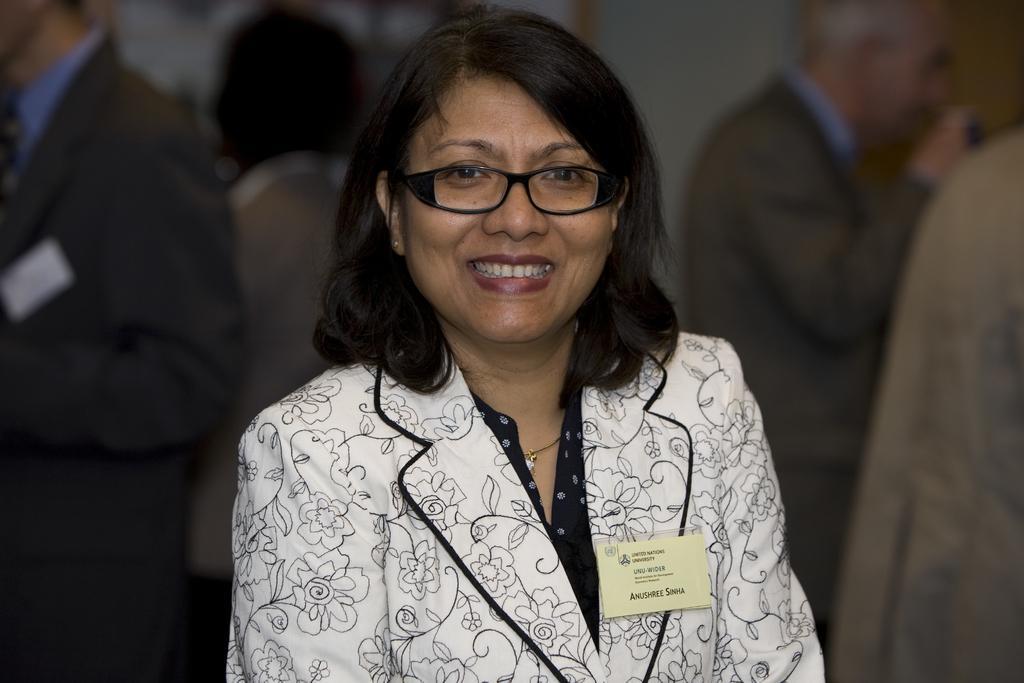Please provide a concise description of this image. In the center of the image we can see a lady and wearing coat, spectacles and smiling. In the background of the image we can see the wall and some persons are standing. 